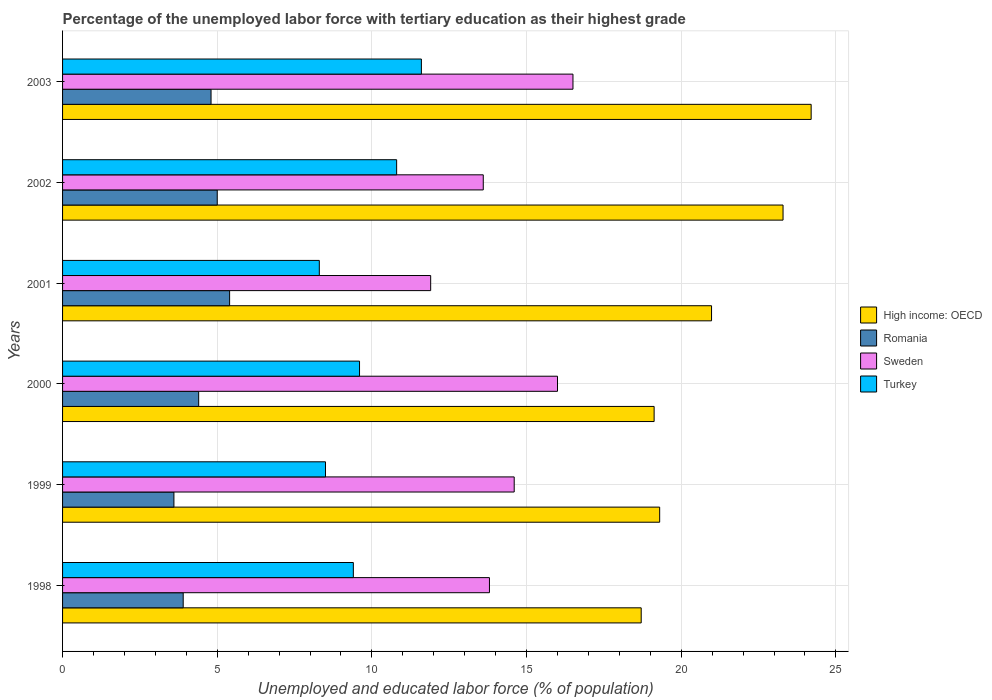How many different coloured bars are there?
Provide a succinct answer. 4. How many groups of bars are there?
Your response must be concise. 6. Are the number of bars on each tick of the Y-axis equal?
Provide a succinct answer. Yes. How many bars are there on the 2nd tick from the top?
Your response must be concise. 4. How many bars are there on the 5th tick from the bottom?
Your response must be concise. 4. In how many cases, is the number of bars for a given year not equal to the number of legend labels?
Give a very brief answer. 0. What is the percentage of the unemployed labor force with tertiary education in High income: OECD in 2001?
Offer a very short reply. 20.98. Across all years, what is the maximum percentage of the unemployed labor force with tertiary education in Sweden?
Your answer should be compact. 16.5. Across all years, what is the minimum percentage of the unemployed labor force with tertiary education in Sweden?
Provide a short and direct response. 11.9. In which year was the percentage of the unemployed labor force with tertiary education in Sweden maximum?
Provide a succinct answer. 2003. What is the total percentage of the unemployed labor force with tertiary education in Sweden in the graph?
Keep it short and to the point. 86.4. What is the difference between the percentage of the unemployed labor force with tertiary education in Turkey in 1998 and that in 2003?
Your answer should be compact. -2.2. What is the difference between the percentage of the unemployed labor force with tertiary education in High income: OECD in 2003 and the percentage of the unemployed labor force with tertiary education in Romania in 2002?
Provide a short and direct response. 19.2. What is the average percentage of the unemployed labor force with tertiary education in Sweden per year?
Give a very brief answer. 14.4. In the year 1999, what is the difference between the percentage of the unemployed labor force with tertiary education in Turkey and percentage of the unemployed labor force with tertiary education in High income: OECD?
Your answer should be very brief. -10.8. What is the ratio of the percentage of the unemployed labor force with tertiary education in Turkey in 1998 to that in 2003?
Your answer should be compact. 0.81. Is the percentage of the unemployed labor force with tertiary education in Romania in 2000 less than that in 2001?
Provide a short and direct response. Yes. Is the difference between the percentage of the unemployed labor force with tertiary education in Turkey in 1999 and 2000 greater than the difference between the percentage of the unemployed labor force with tertiary education in High income: OECD in 1999 and 2000?
Make the answer very short. No. What is the difference between the highest and the second highest percentage of the unemployed labor force with tertiary education in Romania?
Your answer should be very brief. 0.4. What is the difference between the highest and the lowest percentage of the unemployed labor force with tertiary education in High income: OECD?
Give a very brief answer. 5.49. In how many years, is the percentage of the unemployed labor force with tertiary education in Turkey greater than the average percentage of the unemployed labor force with tertiary education in Turkey taken over all years?
Your response must be concise. 2. What does the 1st bar from the top in 2002 represents?
Provide a short and direct response. Turkey. What does the 1st bar from the bottom in 1999 represents?
Your answer should be very brief. High income: OECD. Are the values on the major ticks of X-axis written in scientific E-notation?
Offer a very short reply. No. Where does the legend appear in the graph?
Your answer should be very brief. Center right. How many legend labels are there?
Give a very brief answer. 4. What is the title of the graph?
Give a very brief answer. Percentage of the unemployed labor force with tertiary education as their highest grade. What is the label or title of the X-axis?
Provide a succinct answer. Unemployed and educated labor force (% of population). What is the label or title of the Y-axis?
Offer a terse response. Years. What is the Unemployed and educated labor force (% of population) in High income: OECD in 1998?
Provide a short and direct response. 18.71. What is the Unemployed and educated labor force (% of population) in Romania in 1998?
Give a very brief answer. 3.9. What is the Unemployed and educated labor force (% of population) of Sweden in 1998?
Ensure brevity in your answer.  13.8. What is the Unemployed and educated labor force (% of population) of Turkey in 1998?
Offer a terse response. 9.4. What is the Unemployed and educated labor force (% of population) in High income: OECD in 1999?
Your response must be concise. 19.3. What is the Unemployed and educated labor force (% of population) in Romania in 1999?
Make the answer very short. 3.6. What is the Unemployed and educated labor force (% of population) of Sweden in 1999?
Give a very brief answer. 14.6. What is the Unemployed and educated labor force (% of population) in High income: OECD in 2000?
Give a very brief answer. 19.12. What is the Unemployed and educated labor force (% of population) in Romania in 2000?
Your answer should be compact. 4.4. What is the Unemployed and educated labor force (% of population) of Sweden in 2000?
Make the answer very short. 16. What is the Unemployed and educated labor force (% of population) in Turkey in 2000?
Ensure brevity in your answer.  9.6. What is the Unemployed and educated labor force (% of population) of High income: OECD in 2001?
Offer a terse response. 20.98. What is the Unemployed and educated labor force (% of population) in Romania in 2001?
Your answer should be very brief. 5.4. What is the Unemployed and educated labor force (% of population) of Sweden in 2001?
Your response must be concise. 11.9. What is the Unemployed and educated labor force (% of population) in Turkey in 2001?
Your answer should be very brief. 8.3. What is the Unemployed and educated labor force (% of population) of High income: OECD in 2002?
Keep it short and to the point. 23.29. What is the Unemployed and educated labor force (% of population) in Sweden in 2002?
Keep it short and to the point. 13.6. What is the Unemployed and educated labor force (% of population) of Turkey in 2002?
Your answer should be compact. 10.8. What is the Unemployed and educated labor force (% of population) of High income: OECD in 2003?
Your answer should be compact. 24.2. What is the Unemployed and educated labor force (% of population) of Romania in 2003?
Make the answer very short. 4.8. What is the Unemployed and educated labor force (% of population) of Turkey in 2003?
Make the answer very short. 11.6. Across all years, what is the maximum Unemployed and educated labor force (% of population) in High income: OECD?
Offer a very short reply. 24.2. Across all years, what is the maximum Unemployed and educated labor force (% of population) in Romania?
Give a very brief answer. 5.4. Across all years, what is the maximum Unemployed and educated labor force (% of population) in Sweden?
Offer a very short reply. 16.5. Across all years, what is the maximum Unemployed and educated labor force (% of population) in Turkey?
Make the answer very short. 11.6. Across all years, what is the minimum Unemployed and educated labor force (% of population) in High income: OECD?
Offer a terse response. 18.71. Across all years, what is the minimum Unemployed and educated labor force (% of population) of Romania?
Make the answer very short. 3.6. Across all years, what is the minimum Unemployed and educated labor force (% of population) in Sweden?
Your answer should be very brief. 11.9. Across all years, what is the minimum Unemployed and educated labor force (% of population) in Turkey?
Provide a succinct answer. 8.3. What is the total Unemployed and educated labor force (% of population) in High income: OECD in the graph?
Your answer should be compact. 125.6. What is the total Unemployed and educated labor force (% of population) in Romania in the graph?
Your answer should be very brief. 27.1. What is the total Unemployed and educated labor force (% of population) of Sweden in the graph?
Your answer should be very brief. 86.4. What is the total Unemployed and educated labor force (% of population) in Turkey in the graph?
Provide a short and direct response. 58.2. What is the difference between the Unemployed and educated labor force (% of population) of High income: OECD in 1998 and that in 1999?
Provide a short and direct response. -0.6. What is the difference between the Unemployed and educated labor force (% of population) of Romania in 1998 and that in 1999?
Give a very brief answer. 0.3. What is the difference between the Unemployed and educated labor force (% of population) of Sweden in 1998 and that in 1999?
Make the answer very short. -0.8. What is the difference between the Unemployed and educated labor force (% of population) in High income: OECD in 1998 and that in 2000?
Your answer should be very brief. -0.42. What is the difference between the Unemployed and educated labor force (% of population) in Turkey in 1998 and that in 2000?
Give a very brief answer. -0.2. What is the difference between the Unemployed and educated labor force (% of population) in High income: OECD in 1998 and that in 2001?
Provide a succinct answer. -2.27. What is the difference between the Unemployed and educated labor force (% of population) of Romania in 1998 and that in 2001?
Ensure brevity in your answer.  -1.5. What is the difference between the Unemployed and educated labor force (% of population) of Sweden in 1998 and that in 2001?
Your answer should be very brief. 1.9. What is the difference between the Unemployed and educated labor force (% of population) in Turkey in 1998 and that in 2001?
Your answer should be very brief. 1.1. What is the difference between the Unemployed and educated labor force (% of population) of High income: OECD in 1998 and that in 2002?
Provide a succinct answer. -4.59. What is the difference between the Unemployed and educated labor force (% of population) of Romania in 1998 and that in 2002?
Your answer should be very brief. -1.1. What is the difference between the Unemployed and educated labor force (% of population) of Sweden in 1998 and that in 2002?
Your answer should be compact. 0.2. What is the difference between the Unemployed and educated labor force (% of population) in High income: OECD in 1998 and that in 2003?
Your response must be concise. -5.49. What is the difference between the Unemployed and educated labor force (% of population) in Turkey in 1998 and that in 2003?
Provide a short and direct response. -2.2. What is the difference between the Unemployed and educated labor force (% of population) of High income: OECD in 1999 and that in 2000?
Your response must be concise. 0.18. What is the difference between the Unemployed and educated labor force (% of population) of Romania in 1999 and that in 2000?
Keep it short and to the point. -0.8. What is the difference between the Unemployed and educated labor force (% of population) in High income: OECD in 1999 and that in 2001?
Ensure brevity in your answer.  -1.68. What is the difference between the Unemployed and educated labor force (% of population) of Sweden in 1999 and that in 2001?
Your answer should be compact. 2.7. What is the difference between the Unemployed and educated labor force (% of population) in High income: OECD in 1999 and that in 2002?
Offer a terse response. -3.99. What is the difference between the Unemployed and educated labor force (% of population) in Romania in 1999 and that in 2002?
Offer a terse response. -1.4. What is the difference between the Unemployed and educated labor force (% of population) of Sweden in 1999 and that in 2002?
Your answer should be very brief. 1. What is the difference between the Unemployed and educated labor force (% of population) in Turkey in 1999 and that in 2002?
Offer a very short reply. -2.3. What is the difference between the Unemployed and educated labor force (% of population) of High income: OECD in 1999 and that in 2003?
Offer a terse response. -4.9. What is the difference between the Unemployed and educated labor force (% of population) in Romania in 1999 and that in 2003?
Keep it short and to the point. -1.2. What is the difference between the Unemployed and educated labor force (% of population) of Sweden in 1999 and that in 2003?
Provide a short and direct response. -1.9. What is the difference between the Unemployed and educated labor force (% of population) of High income: OECD in 2000 and that in 2001?
Provide a short and direct response. -1.86. What is the difference between the Unemployed and educated labor force (% of population) in Sweden in 2000 and that in 2001?
Keep it short and to the point. 4.1. What is the difference between the Unemployed and educated labor force (% of population) in High income: OECD in 2000 and that in 2002?
Provide a succinct answer. -4.17. What is the difference between the Unemployed and educated labor force (% of population) of Romania in 2000 and that in 2002?
Your answer should be compact. -0.6. What is the difference between the Unemployed and educated labor force (% of population) in Sweden in 2000 and that in 2002?
Keep it short and to the point. 2.4. What is the difference between the Unemployed and educated labor force (% of population) in High income: OECD in 2000 and that in 2003?
Your response must be concise. -5.08. What is the difference between the Unemployed and educated labor force (% of population) of Romania in 2000 and that in 2003?
Keep it short and to the point. -0.4. What is the difference between the Unemployed and educated labor force (% of population) of High income: OECD in 2001 and that in 2002?
Your response must be concise. -2.31. What is the difference between the Unemployed and educated labor force (% of population) in Sweden in 2001 and that in 2002?
Offer a terse response. -1.7. What is the difference between the Unemployed and educated labor force (% of population) of Turkey in 2001 and that in 2002?
Your answer should be compact. -2.5. What is the difference between the Unemployed and educated labor force (% of population) in High income: OECD in 2001 and that in 2003?
Provide a short and direct response. -3.22. What is the difference between the Unemployed and educated labor force (% of population) in Turkey in 2001 and that in 2003?
Offer a very short reply. -3.3. What is the difference between the Unemployed and educated labor force (% of population) of High income: OECD in 2002 and that in 2003?
Keep it short and to the point. -0.91. What is the difference between the Unemployed and educated labor force (% of population) in Romania in 2002 and that in 2003?
Offer a very short reply. 0.2. What is the difference between the Unemployed and educated labor force (% of population) in Turkey in 2002 and that in 2003?
Your answer should be very brief. -0.8. What is the difference between the Unemployed and educated labor force (% of population) of High income: OECD in 1998 and the Unemployed and educated labor force (% of population) of Romania in 1999?
Provide a short and direct response. 15.11. What is the difference between the Unemployed and educated labor force (% of population) in High income: OECD in 1998 and the Unemployed and educated labor force (% of population) in Sweden in 1999?
Offer a very short reply. 4.11. What is the difference between the Unemployed and educated labor force (% of population) of High income: OECD in 1998 and the Unemployed and educated labor force (% of population) of Turkey in 1999?
Your response must be concise. 10.21. What is the difference between the Unemployed and educated labor force (% of population) of Romania in 1998 and the Unemployed and educated labor force (% of population) of Sweden in 1999?
Your answer should be compact. -10.7. What is the difference between the Unemployed and educated labor force (% of population) in Sweden in 1998 and the Unemployed and educated labor force (% of population) in Turkey in 1999?
Offer a terse response. 5.3. What is the difference between the Unemployed and educated labor force (% of population) of High income: OECD in 1998 and the Unemployed and educated labor force (% of population) of Romania in 2000?
Your answer should be very brief. 14.31. What is the difference between the Unemployed and educated labor force (% of population) in High income: OECD in 1998 and the Unemployed and educated labor force (% of population) in Sweden in 2000?
Provide a succinct answer. 2.71. What is the difference between the Unemployed and educated labor force (% of population) of High income: OECD in 1998 and the Unemployed and educated labor force (% of population) of Turkey in 2000?
Your answer should be compact. 9.11. What is the difference between the Unemployed and educated labor force (% of population) in Romania in 1998 and the Unemployed and educated labor force (% of population) in Sweden in 2000?
Your response must be concise. -12.1. What is the difference between the Unemployed and educated labor force (% of population) in Romania in 1998 and the Unemployed and educated labor force (% of population) in Turkey in 2000?
Your answer should be very brief. -5.7. What is the difference between the Unemployed and educated labor force (% of population) in High income: OECD in 1998 and the Unemployed and educated labor force (% of population) in Romania in 2001?
Provide a short and direct response. 13.31. What is the difference between the Unemployed and educated labor force (% of population) in High income: OECD in 1998 and the Unemployed and educated labor force (% of population) in Sweden in 2001?
Keep it short and to the point. 6.81. What is the difference between the Unemployed and educated labor force (% of population) of High income: OECD in 1998 and the Unemployed and educated labor force (% of population) of Turkey in 2001?
Your answer should be very brief. 10.41. What is the difference between the Unemployed and educated labor force (% of population) of Romania in 1998 and the Unemployed and educated labor force (% of population) of Sweden in 2001?
Give a very brief answer. -8. What is the difference between the Unemployed and educated labor force (% of population) in Sweden in 1998 and the Unemployed and educated labor force (% of population) in Turkey in 2001?
Give a very brief answer. 5.5. What is the difference between the Unemployed and educated labor force (% of population) in High income: OECD in 1998 and the Unemployed and educated labor force (% of population) in Romania in 2002?
Your answer should be very brief. 13.71. What is the difference between the Unemployed and educated labor force (% of population) of High income: OECD in 1998 and the Unemployed and educated labor force (% of population) of Sweden in 2002?
Offer a very short reply. 5.11. What is the difference between the Unemployed and educated labor force (% of population) in High income: OECD in 1998 and the Unemployed and educated labor force (% of population) in Turkey in 2002?
Ensure brevity in your answer.  7.91. What is the difference between the Unemployed and educated labor force (% of population) of Romania in 1998 and the Unemployed and educated labor force (% of population) of Sweden in 2002?
Your answer should be very brief. -9.7. What is the difference between the Unemployed and educated labor force (% of population) of Romania in 1998 and the Unemployed and educated labor force (% of population) of Turkey in 2002?
Make the answer very short. -6.9. What is the difference between the Unemployed and educated labor force (% of population) of High income: OECD in 1998 and the Unemployed and educated labor force (% of population) of Romania in 2003?
Keep it short and to the point. 13.91. What is the difference between the Unemployed and educated labor force (% of population) in High income: OECD in 1998 and the Unemployed and educated labor force (% of population) in Sweden in 2003?
Provide a short and direct response. 2.21. What is the difference between the Unemployed and educated labor force (% of population) in High income: OECD in 1998 and the Unemployed and educated labor force (% of population) in Turkey in 2003?
Your answer should be compact. 7.11. What is the difference between the Unemployed and educated labor force (% of population) in Romania in 1998 and the Unemployed and educated labor force (% of population) in Sweden in 2003?
Provide a short and direct response. -12.6. What is the difference between the Unemployed and educated labor force (% of population) in Romania in 1998 and the Unemployed and educated labor force (% of population) in Turkey in 2003?
Provide a short and direct response. -7.7. What is the difference between the Unemployed and educated labor force (% of population) in High income: OECD in 1999 and the Unemployed and educated labor force (% of population) in Romania in 2000?
Your answer should be compact. 14.9. What is the difference between the Unemployed and educated labor force (% of population) in High income: OECD in 1999 and the Unemployed and educated labor force (% of population) in Sweden in 2000?
Provide a succinct answer. 3.3. What is the difference between the Unemployed and educated labor force (% of population) in High income: OECD in 1999 and the Unemployed and educated labor force (% of population) in Turkey in 2000?
Keep it short and to the point. 9.7. What is the difference between the Unemployed and educated labor force (% of population) in Romania in 1999 and the Unemployed and educated labor force (% of population) in Sweden in 2000?
Give a very brief answer. -12.4. What is the difference between the Unemployed and educated labor force (% of population) in High income: OECD in 1999 and the Unemployed and educated labor force (% of population) in Romania in 2001?
Your answer should be very brief. 13.9. What is the difference between the Unemployed and educated labor force (% of population) in High income: OECD in 1999 and the Unemployed and educated labor force (% of population) in Sweden in 2001?
Offer a terse response. 7.4. What is the difference between the Unemployed and educated labor force (% of population) in High income: OECD in 1999 and the Unemployed and educated labor force (% of population) in Turkey in 2001?
Your response must be concise. 11. What is the difference between the Unemployed and educated labor force (% of population) of Sweden in 1999 and the Unemployed and educated labor force (% of population) of Turkey in 2001?
Offer a very short reply. 6.3. What is the difference between the Unemployed and educated labor force (% of population) of High income: OECD in 1999 and the Unemployed and educated labor force (% of population) of Romania in 2002?
Provide a short and direct response. 14.3. What is the difference between the Unemployed and educated labor force (% of population) of High income: OECD in 1999 and the Unemployed and educated labor force (% of population) of Sweden in 2002?
Offer a very short reply. 5.7. What is the difference between the Unemployed and educated labor force (% of population) in High income: OECD in 1999 and the Unemployed and educated labor force (% of population) in Turkey in 2002?
Ensure brevity in your answer.  8.5. What is the difference between the Unemployed and educated labor force (% of population) of Sweden in 1999 and the Unemployed and educated labor force (% of population) of Turkey in 2002?
Give a very brief answer. 3.8. What is the difference between the Unemployed and educated labor force (% of population) of High income: OECD in 1999 and the Unemployed and educated labor force (% of population) of Romania in 2003?
Your response must be concise. 14.5. What is the difference between the Unemployed and educated labor force (% of population) of High income: OECD in 1999 and the Unemployed and educated labor force (% of population) of Sweden in 2003?
Ensure brevity in your answer.  2.8. What is the difference between the Unemployed and educated labor force (% of population) of High income: OECD in 1999 and the Unemployed and educated labor force (% of population) of Turkey in 2003?
Give a very brief answer. 7.7. What is the difference between the Unemployed and educated labor force (% of population) in Romania in 1999 and the Unemployed and educated labor force (% of population) in Turkey in 2003?
Your response must be concise. -8. What is the difference between the Unemployed and educated labor force (% of population) of Sweden in 1999 and the Unemployed and educated labor force (% of population) of Turkey in 2003?
Keep it short and to the point. 3. What is the difference between the Unemployed and educated labor force (% of population) in High income: OECD in 2000 and the Unemployed and educated labor force (% of population) in Romania in 2001?
Offer a very short reply. 13.72. What is the difference between the Unemployed and educated labor force (% of population) of High income: OECD in 2000 and the Unemployed and educated labor force (% of population) of Sweden in 2001?
Provide a succinct answer. 7.22. What is the difference between the Unemployed and educated labor force (% of population) in High income: OECD in 2000 and the Unemployed and educated labor force (% of population) in Turkey in 2001?
Give a very brief answer. 10.82. What is the difference between the Unemployed and educated labor force (% of population) of Sweden in 2000 and the Unemployed and educated labor force (% of population) of Turkey in 2001?
Give a very brief answer. 7.7. What is the difference between the Unemployed and educated labor force (% of population) of High income: OECD in 2000 and the Unemployed and educated labor force (% of population) of Romania in 2002?
Ensure brevity in your answer.  14.12. What is the difference between the Unemployed and educated labor force (% of population) in High income: OECD in 2000 and the Unemployed and educated labor force (% of population) in Sweden in 2002?
Keep it short and to the point. 5.52. What is the difference between the Unemployed and educated labor force (% of population) in High income: OECD in 2000 and the Unemployed and educated labor force (% of population) in Turkey in 2002?
Give a very brief answer. 8.32. What is the difference between the Unemployed and educated labor force (% of population) in Romania in 2000 and the Unemployed and educated labor force (% of population) in Sweden in 2002?
Make the answer very short. -9.2. What is the difference between the Unemployed and educated labor force (% of population) in Sweden in 2000 and the Unemployed and educated labor force (% of population) in Turkey in 2002?
Offer a terse response. 5.2. What is the difference between the Unemployed and educated labor force (% of population) of High income: OECD in 2000 and the Unemployed and educated labor force (% of population) of Romania in 2003?
Make the answer very short. 14.32. What is the difference between the Unemployed and educated labor force (% of population) of High income: OECD in 2000 and the Unemployed and educated labor force (% of population) of Sweden in 2003?
Offer a very short reply. 2.62. What is the difference between the Unemployed and educated labor force (% of population) in High income: OECD in 2000 and the Unemployed and educated labor force (% of population) in Turkey in 2003?
Give a very brief answer. 7.52. What is the difference between the Unemployed and educated labor force (% of population) in Romania in 2000 and the Unemployed and educated labor force (% of population) in Sweden in 2003?
Your response must be concise. -12.1. What is the difference between the Unemployed and educated labor force (% of population) of Sweden in 2000 and the Unemployed and educated labor force (% of population) of Turkey in 2003?
Offer a terse response. 4.4. What is the difference between the Unemployed and educated labor force (% of population) in High income: OECD in 2001 and the Unemployed and educated labor force (% of population) in Romania in 2002?
Provide a succinct answer. 15.98. What is the difference between the Unemployed and educated labor force (% of population) in High income: OECD in 2001 and the Unemployed and educated labor force (% of population) in Sweden in 2002?
Your answer should be very brief. 7.38. What is the difference between the Unemployed and educated labor force (% of population) in High income: OECD in 2001 and the Unemployed and educated labor force (% of population) in Turkey in 2002?
Provide a short and direct response. 10.18. What is the difference between the Unemployed and educated labor force (% of population) of High income: OECD in 2001 and the Unemployed and educated labor force (% of population) of Romania in 2003?
Your answer should be very brief. 16.18. What is the difference between the Unemployed and educated labor force (% of population) in High income: OECD in 2001 and the Unemployed and educated labor force (% of population) in Sweden in 2003?
Offer a terse response. 4.48. What is the difference between the Unemployed and educated labor force (% of population) in High income: OECD in 2001 and the Unemployed and educated labor force (% of population) in Turkey in 2003?
Provide a short and direct response. 9.38. What is the difference between the Unemployed and educated labor force (% of population) in Sweden in 2001 and the Unemployed and educated labor force (% of population) in Turkey in 2003?
Ensure brevity in your answer.  0.3. What is the difference between the Unemployed and educated labor force (% of population) in High income: OECD in 2002 and the Unemployed and educated labor force (% of population) in Romania in 2003?
Provide a short and direct response. 18.49. What is the difference between the Unemployed and educated labor force (% of population) in High income: OECD in 2002 and the Unemployed and educated labor force (% of population) in Sweden in 2003?
Give a very brief answer. 6.79. What is the difference between the Unemployed and educated labor force (% of population) of High income: OECD in 2002 and the Unemployed and educated labor force (% of population) of Turkey in 2003?
Give a very brief answer. 11.69. What is the average Unemployed and educated labor force (% of population) in High income: OECD per year?
Keep it short and to the point. 20.93. What is the average Unemployed and educated labor force (% of population) in Romania per year?
Make the answer very short. 4.52. What is the average Unemployed and educated labor force (% of population) of Sweden per year?
Ensure brevity in your answer.  14.4. In the year 1998, what is the difference between the Unemployed and educated labor force (% of population) of High income: OECD and Unemployed and educated labor force (% of population) of Romania?
Make the answer very short. 14.81. In the year 1998, what is the difference between the Unemployed and educated labor force (% of population) of High income: OECD and Unemployed and educated labor force (% of population) of Sweden?
Ensure brevity in your answer.  4.91. In the year 1998, what is the difference between the Unemployed and educated labor force (% of population) in High income: OECD and Unemployed and educated labor force (% of population) in Turkey?
Keep it short and to the point. 9.31. In the year 1998, what is the difference between the Unemployed and educated labor force (% of population) in Romania and Unemployed and educated labor force (% of population) in Sweden?
Offer a very short reply. -9.9. In the year 1999, what is the difference between the Unemployed and educated labor force (% of population) of High income: OECD and Unemployed and educated labor force (% of population) of Romania?
Your answer should be very brief. 15.7. In the year 1999, what is the difference between the Unemployed and educated labor force (% of population) of High income: OECD and Unemployed and educated labor force (% of population) of Sweden?
Your answer should be very brief. 4.7. In the year 1999, what is the difference between the Unemployed and educated labor force (% of population) of High income: OECD and Unemployed and educated labor force (% of population) of Turkey?
Your response must be concise. 10.8. In the year 1999, what is the difference between the Unemployed and educated labor force (% of population) of Romania and Unemployed and educated labor force (% of population) of Sweden?
Ensure brevity in your answer.  -11. In the year 1999, what is the difference between the Unemployed and educated labor force (% of population) of Romania and Unemployed and educated labor force (% of population) of Turkey?
Your response must be concise. -4.9. In the year 2000, what is the difference between the Unemployed and educated labor force (% of population) in High income: OECD and Unemployed and educated labor force (% of population) in Romania?
Provide a short and direct response. 14.72. In the year 2000, what is the difference between the Unemployed and educated labor force (% of population) of High income: OECD and Unemployed and educated labor force (% of population) of Sweden?
Offer a very short reply. 3.12. In the year 2000, what is the difference between the Unemployed and educated labor force (% of population) of High income: OECD and Unemployed and educated labor force (% of population) of Turkey?
Your answer should be compact. 9.52. In the year 2000, what is the difference between the Unemployed and educated labor force (% of population) in Romania and Unemployed and educated labor force (% of population) in Turkey?
Provide a short and direct response. -5.2. In the year 2000, what is the difference between the Unemployed and educated labor force (% of population) in Sweden and Unemployed and educated labor force (% of population) in Turkey?
Ensure brevity in your answer.  6.4. In the year 2001, what is the difference between the Unemployed and educated labor force (% of population) in High income: OECD and Unemployed and educated labor force (% of population) in Romania?
Ensure brevity in your answer.  15.58. In the year 2001, what is the difference between the Unemployed and educated labor force (% of population) in High income: OECD and Unemployed and educated labor force (% of population) in Sweden?
Ensure brevity in your answer.  9.08. In the year 2001, what is the difference between the Unemployed and educated labor force (% of population) in High income: OECD and Unemployed and educated labor force (% of population) in Turkey?
Keep it short and to the point. 12.68. In the year 2001, what is the difference between the Unemployed and educated labor force (% of population) in Romania and Unemployed and educated labor force (% of population) in Sweden?
Your response must be concise. -6.5. In the year 2002, what is the difference between the Unemployed and educated labor force (% of population) in High income: OECD and Unemployed and educated labor force (% of population) in Romania?
Keep it short and to the point. 18.29. In the year 2002, what is the difference between the Unemployed and educated labor force (% of population) in High income: OECD and Unemployed and educated labor force (% of population) in Sweden?
Your answer should be compact. 9.69. In the year 2002, what is the difference between the Unemployed and educated labor force (% of population) in High income: OECD and Unemployed and educated labor force (% of population) in Turkey?
Provide a short and direct response. 12.49. In the year 2002, what is the difference between the Unemployed and educated labor force (% of population) of Romania and Unemployed and educated labor force (% of population) of Sweden?
Offer a terse response. -8.6. In the year 2002, what is the difference between the Unemployed and educated labor force (% of population) of Romania and Unemployed and educated labor force (% of population) of Turkey?
Keep it short and to the point. -5.8. In the year 2002, what is the difference between the Unemployed and educated labor force (% of population) of Sweden and Unemployed and educated labor force (% of population) of Turkey?
Your response must be concise. 2.8. In the year 2003, what is the difference between the Unemployed and educated labor force (% of population) of High income: OECD and Unemployed and educated labor force (% of population) of Romania?
Provide a succinct answer. 19.4. In the year 2003, what is the difference between the Unemployed and educated labor force (% of population) in Romania and Unemployed and educated labor force (% of population) in Sweden?
Keep it short and to the point. -11.7. What is the ratio of the Unemployed and educated labor force (% of population) in High income: OECD in 1998 to that in 1999?
Provide a short and direct response. 0.97. What is the ratio of the Unemployed and educated labor force (% of population) in Romania in 1998 to that in 1999?
Your answer should be very brief. 1.08. What is the ratio of the Unemployed and educated labor force (% of population) in Sweden in 1998 to that in 1999?
Keep it short and to the point. 0.95. What is the ratio of the Unemployed and educated labor force (% of population) of Turkey in 1998 to that in 1999?
Make the answer very short. 1.11. What is the ratio of the Unemployed and educated labor force (% of population) in High income: OECD in 1998 to that in 2000?
Ensure brevity in your answer.  0.98. What is the ratio of the Unemployed and educated labor force (% of population) of Romania in 1998 to that in 2000?
Keep it short and to the point. 0.89. What is the ratio of the Unemployed and educated labor force (% of population) of Sweden in 1998 to that in 2000?
Offer a very short reply. 0.86. What is the ratio of the Unemployed and educated labor force (% of population) in Turkey in 1998 to that in 2000?
Keep it short and to the point. 0.98. What is the ratio of the Unemployed and educated labor force (% of population) in High income: OECD in 1998 to that in 2001?
Give a very brief answer. 0.89. What is the ratio of the Unemployed and educated labor force (% of population) of Romania in 1998 to that in 2001?
Ensure brevity in your answer.  0.72. What is the ratio of the Unemployed and educated labor force (% of population) in Sweden in 1998 to that in 2001?
Provide a short and direct response. 1.16. What is the ratio of the Unemployed and educated labor force (% of population) in Turkey in 1998 to that in 2001?
Make the answer very short. 1.13. What is the ratio of the Unemployed and educated labor force (% of population) in High income: OECD in 1998 to that in 2002?
Offer a very short reply. 0.8. What is the ratio of the Unemployed and educated labor force (% of population) of Romania in 1998 to that in 2002?
Provide a succinct answer. 0.78. What is the ratio of the Unemployed and educated labor force (% of population) in Sweden in 1998 to that in 2002?
Offer a terse response. 1.01. What is the ratio of the Unemployed and educated labor force (% of population) in Turkey in 1998 to that in 2002?
Your response must be concise. 0.87. What is the ratio of the Unemployed and educated labor force (% of population) of High income: OECD in 1998 to that in 2003?
Provide a succinct answer. 0.77. What is the ratio of the Unemployed and educated labor force (% of population) in Romania in 1998 to that in 2003?
Your answer should be very brief. 0.81. What is the ratio of the Unemployed and educated labor force (% of population) in Sweden in 1998 to that in 2003?
Give a very brief answer. 0.84. What is the ratio of the Unemployed and educated labor force (% of population) of Turkey in 1998 to that in 2003?
Offer a terse response. 0.81. What is the ratio of the Unemployed and educated labor force (% of population) in High income: OECD in 1999 to that in 2000?
Provide a succinct answer. 1.01. What is the ratio of the Unemployed and educated labor force (% of population) of Romania in 1999 to that in 2000?
Your answer should be very brief. 0.82. What is the ratio of the Unemployed and educated labor force (% of population) of Sweden in 1999 to that in 2000?
Offer a very short reply. 0.91. What is the ratio of the Unemployed and educated labor force (% of population) of Turkey in 1999 to that in 2000?
Offer a terse response. 0.89. What is the ratio of the Unemployed and educated labor force (% of population) of High income: OECD in 1999 to that in 2001?
Provide a short and direct response. 0.92. What is the ratio of the Unemployed and educated labor force (% of population) in Sweden in 1999 to that in 2001?
Ensure brevity in your answer.  1.23. What is the ratio of the Unemployed and educated labor force (% of population) in Turkey in 1999 to that in 2001?
Offer a very short reply. 1.02. What is the ratio of the Unemployed and educated labor force (% of population) of High income: OECD in 1999 to that in 2002?
Offer a terse response. 0.83. What is the ratio of the Unemployed and educated labor force (% of population) in Romania in 1999 to that in 2002?
Keep it short and to the point. 0.72. What is the ratio of the Unemployed and educated labor force (% of population) of Sweden in 1999 to that in 2002?
Provide a short and direct response. 1.07. What is the ratio of the Unemployed and educated labor force (% of population) in Turkey in 1999 to that in 2002?
Ensure brevity in your answer.  0.79. What is the ratio of the Unemployed and educated labor force (% of population) of High income: OECD in 1999 to that in 2003?
Offer a very short reply. 0.8. What is the ratio of the Unemployed and educated labor force (% of population) in Sweden in 1999 to that in 2003?
Your answer should be compact. 0.88. What is the ratio of the Unemployed and educated labor force (% of population) of Turkey in 1999 to that in 2003?
Keep it short and to the point. 0.73. What is the ratio of the Unemployed and educated labor force (% of population) of High income: OECD in 2000 to that in 2001?
Ensure brevity in your answer.  0.91. What is the ratio of the Unemployed and educated labor force (% of population) of Romania in 2000 to that in 2001?
Offer a terse response. 0.81. What is the ratio of the Unemployed and educated labor force (% of population) in Sweden in 2000 to that in 2001?
Provide a succinct answer. 1.34. What is the ratio of the Unemployed and educated labor force (% of population) in Turkey in 2000 to that in 2001?
Provide a short and direct response. 1.16. What is the ratio of the Unemployed and educated labor force (% of population) in High income: OECD in 2000 to that in 2002?
Keep it short and to the point. 0.82. What is the ratio of the Unemployed and educated labor force (% of population) of Sweden in 2000 to that in 2002?
Offer a very short reply. 1.18. What is the ratio of the Unemployed and educated labor force (% of population) in High income: OECD in 2000 to that in 2003?
Give a very brief answer. 0.79. What is the ratio of the Unemployed and educated labor force (% of population) in Sweden in 2000 to that in 2003?
Provide a succinct answer. 0.97. What is the ratio of the Unemployed and educated labor force (% of population) in Turkey in 2000 to that in 2003?
Your response must be concise. 0.83. What is the ratio of the Unemployed and educated labor force (% of population) of High income: OECD in 2001 to that in 2002?
Your response must be concise. 0.9. What is the ratio of the Unemployed and educated labor force (% of population) in Romania in 2001 to that in 2002?
Keep it short and to the point. 1.08. What is the ratio of the Unemployed and educated labor force (% of population) in Sweden in 2001 to that in 2002?
Make the answer very short. 0.88. What is the ratio of the Unemployed and educated labor force (% of population) in Turkey in 2001 to that in 2002?
Make the answer very short. 0.77. What is the ratio of the Unemployed and educated labor force (% of population) in High income: OECD in 2001 to that in 2003?
Ensure brevity in your answer.  0.87. What is the ratio of the Unemployed and educated labor force (% of population) in Sweden in 2001 to that in 2003?
Your answer should be very brief. 0.72. What is the ratio of the Unemployed and educated labor force (% of population) of Turkey in 2001 to that in 2003?
Make the answer very short. 0.72. What is the ratio of the Unemployed and educated labor force (% of population) in High income: OECD in 2002 to that in 2003?
Keep it short and to the point. 0.96. What is the ratio of the Unemployed and educated labor force (% of population) in Romania in 2002 to that in 2003?
Keep it short and to the point. 1.04. What is the ratio of the Unemployed and educated labor force (% of population) in Sweden in 2002 to that in 2003?
Offer a terse response. 0.82. What is the ratio of the Unemployed and educated labor force (% of population) of Turkey in 2002 to that in 2003?
Offer a terse response. 0.93. What is the difference between the highest and the second highest Unemployed and educated labor force (% of population) of High income: OECD?
Your response must be concise. 0.91. What is the difference between the highest and the lowest Unemployed and educated labor force (% of population) of High income: OECD?
Keep it short and to the point. 5.49. What is the difference between the highest and the lowest Unemployed and educated labor force (% of population) of Romania?
Offer a terse response. 1.8. What is the difference between the highest and the lowest Unemployed and educated labor force (% of population) of Sweden?
Provide a succinct answer. 4.6. 